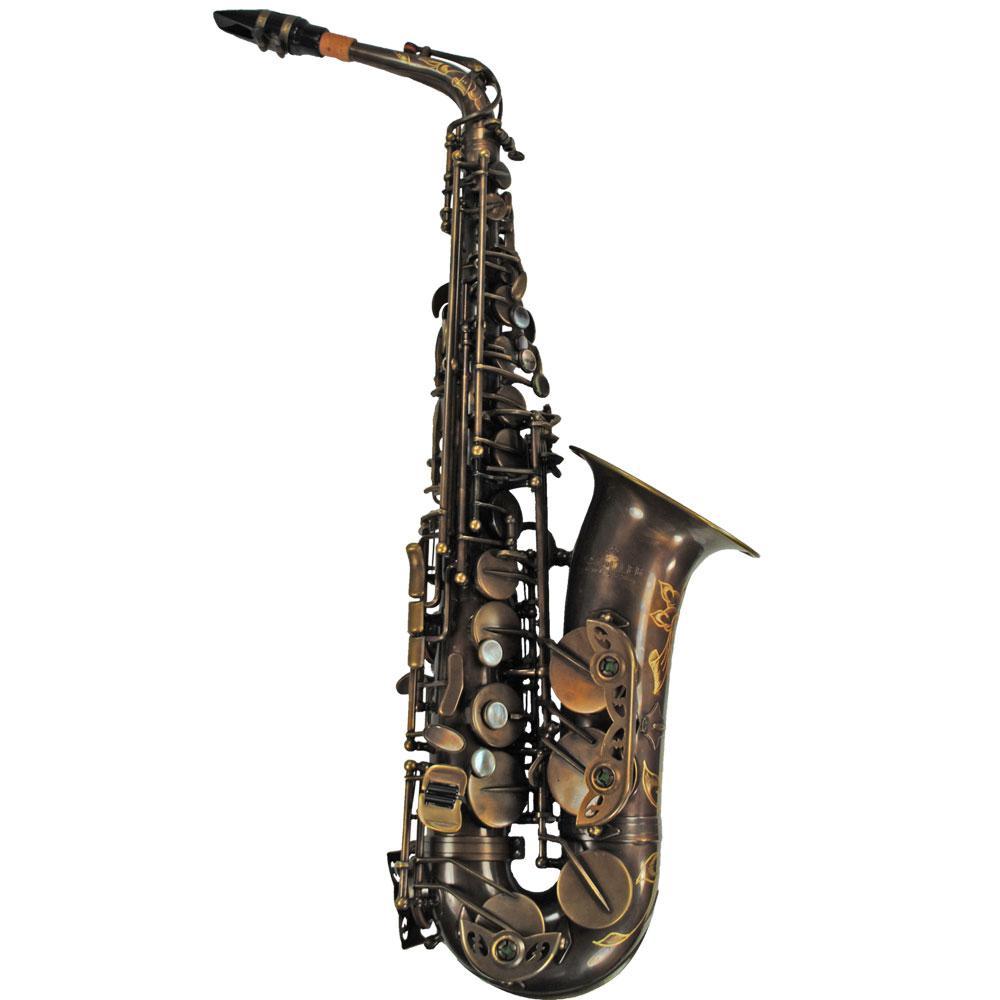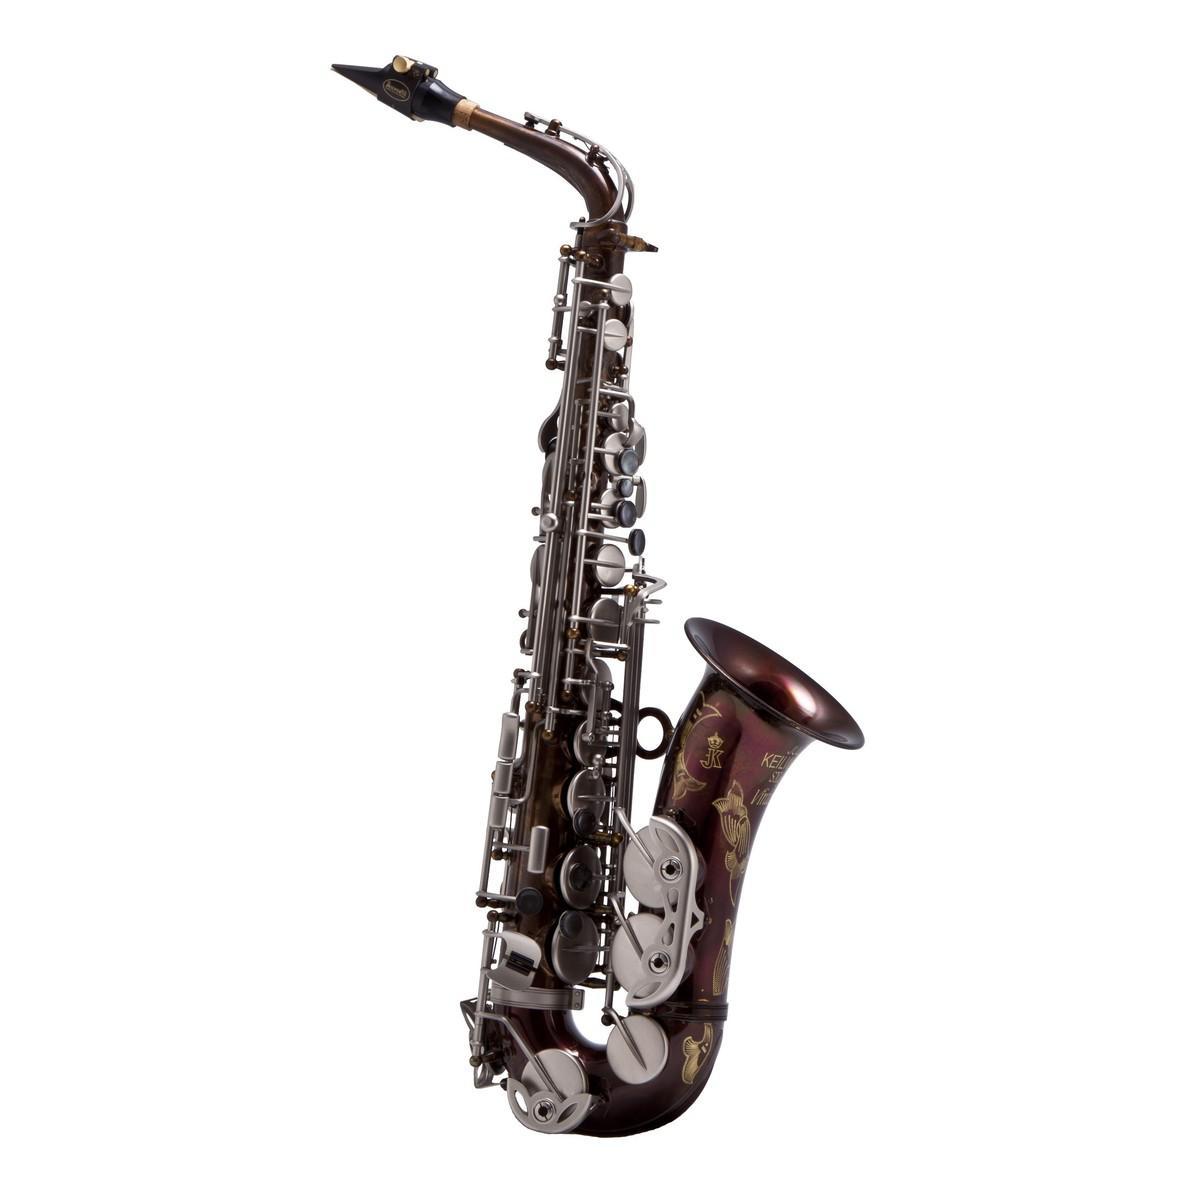The first image is the image on the left, the second image is the image on the right. Considering the images on both sides, is "The saxophones are all sitting upright and facing to the right." valid? Answer yes or no. Yes. The first image is the image on the left, the second image is the image on the right. Given the left and right images, does the statement "There is a vintage saxophone in the center of both images." hold true? Answer yes or no. Yes. 